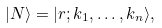<formula> <loc_0><loc_0><loc_500><loc_500>| N \rangle = | r ; k _ { 1 } , \dots , k _ { n } \rangle ,</formula> 